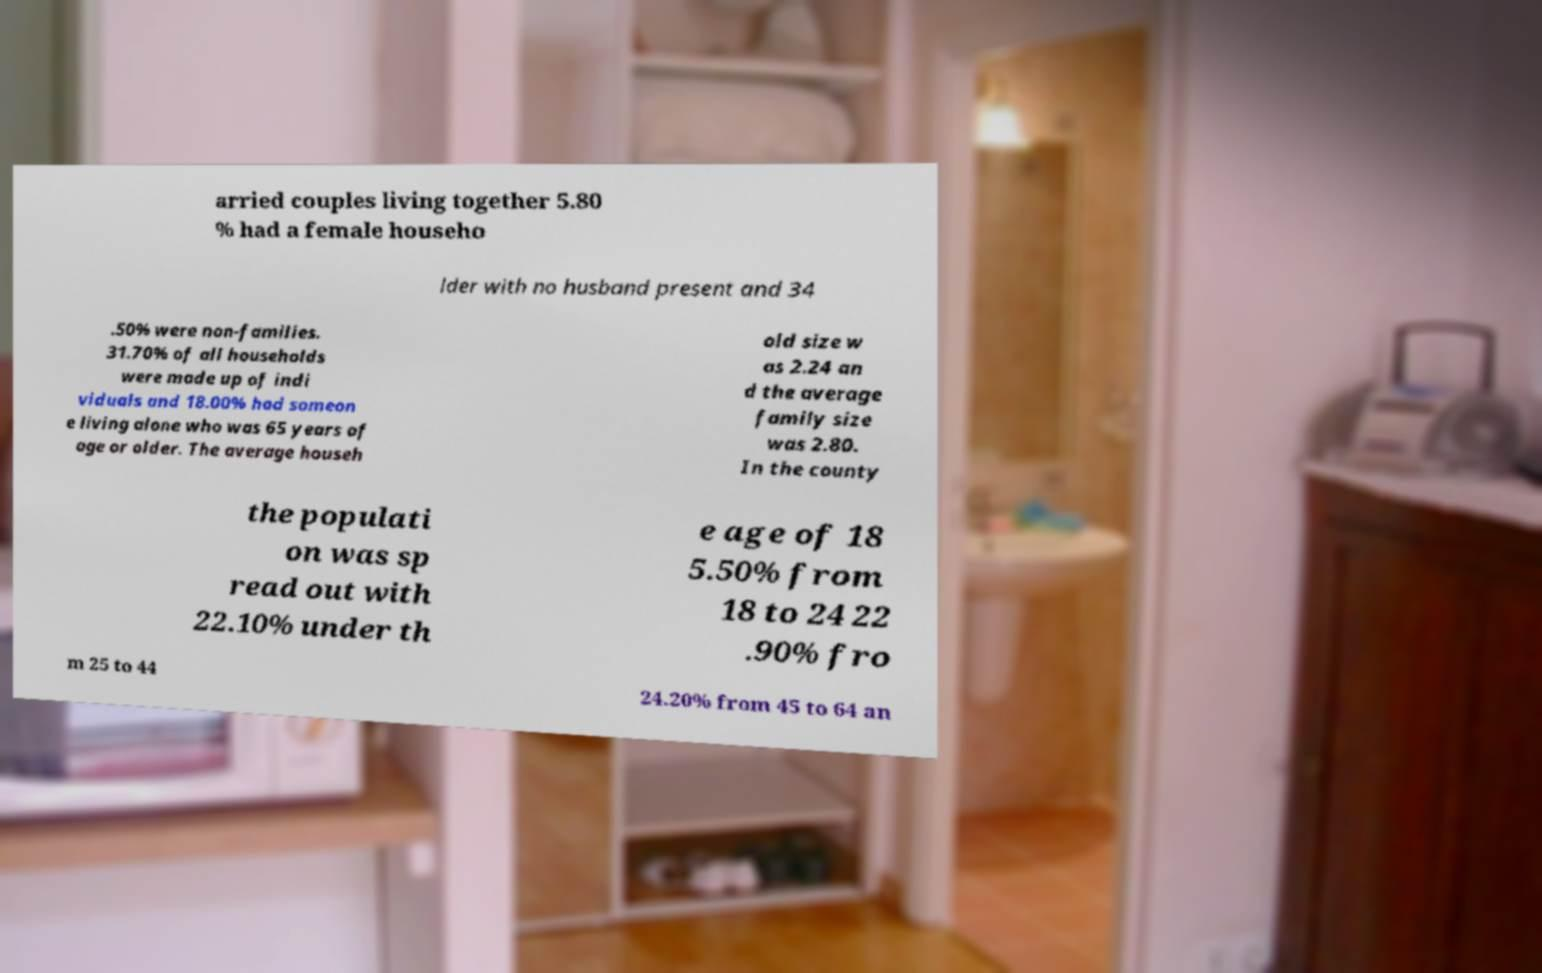Could you assist in decoding the text presented in this image and type it out clearly? arried couples living together 5.80 % had a female househo lder with no husband present and 34 .50% were non-families. 31.70% of all households were made up of indi viduals and 18.00% had someon e living alone who was 65 years of age or older. The average househ old size w as 2.24 an d the average family size was 2.80. In the county the populati on was sp read out with 22.10% under th e age of 18 5.50% from 18 to 24 22 .90% fro m 25 to 44 24.20% from 45 to 64 an 